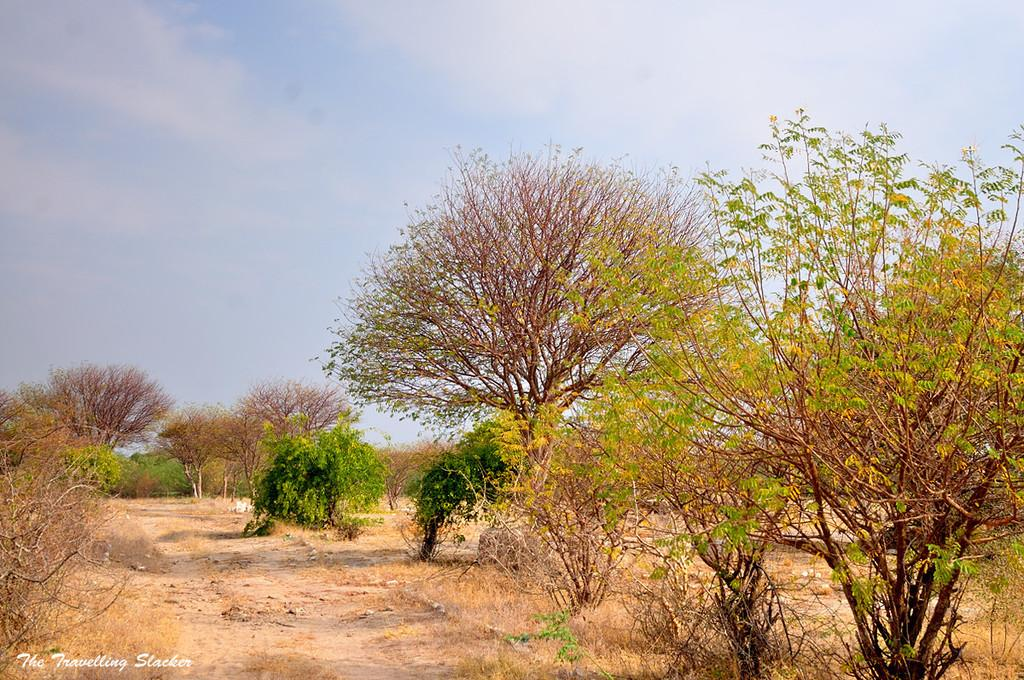What type of terrain is visible in the picture? There is land in the picture. What can be found on the land? There are trees on the land. Are all the trees in the same condition? No, some of the trees are dried up. What type of vest is the coach wearing in the picture? There is no coach or vest present in the picture; it only features land and trees. 